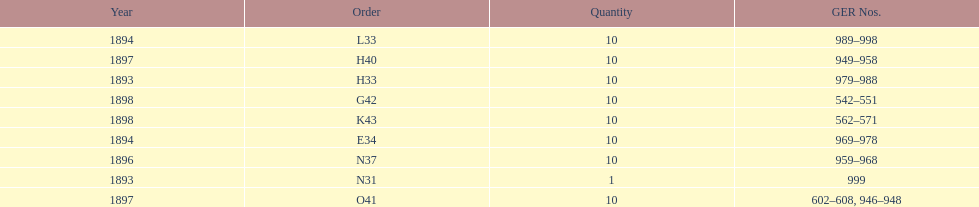Was the quantity higher in 1894 or 1893? 1894. 